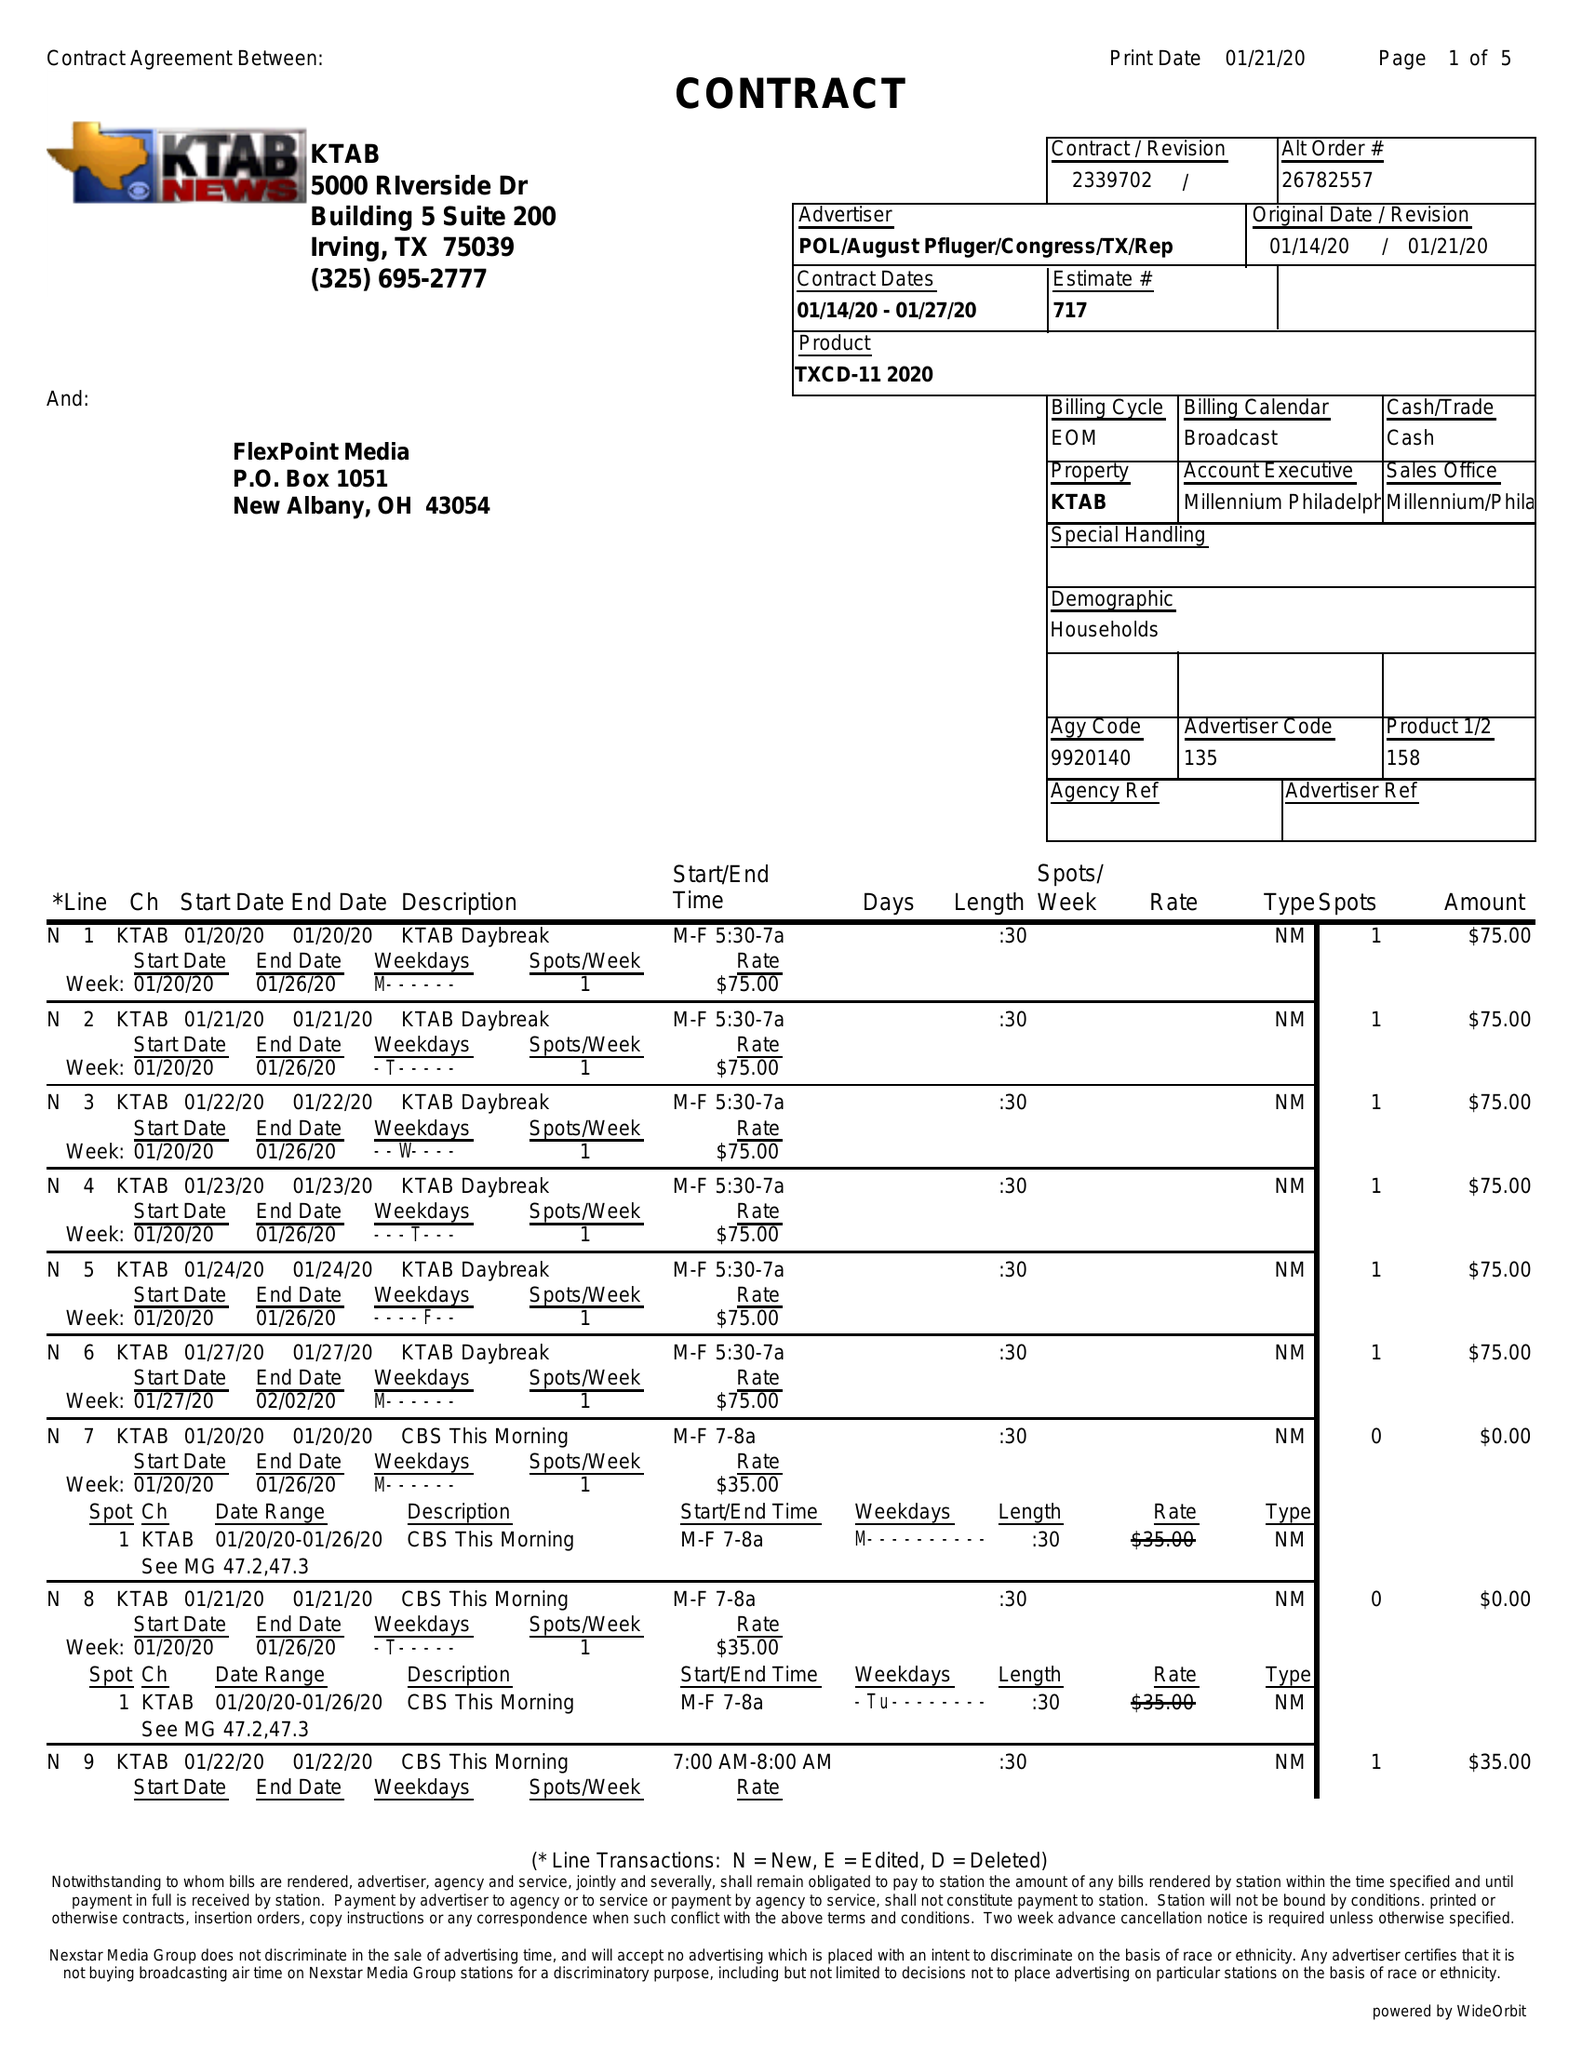What is the value for the advertiser?
Answer the question using a single word or phrase. POL/AUGUSTPFLUGER/CONGRESS/TX/REP 